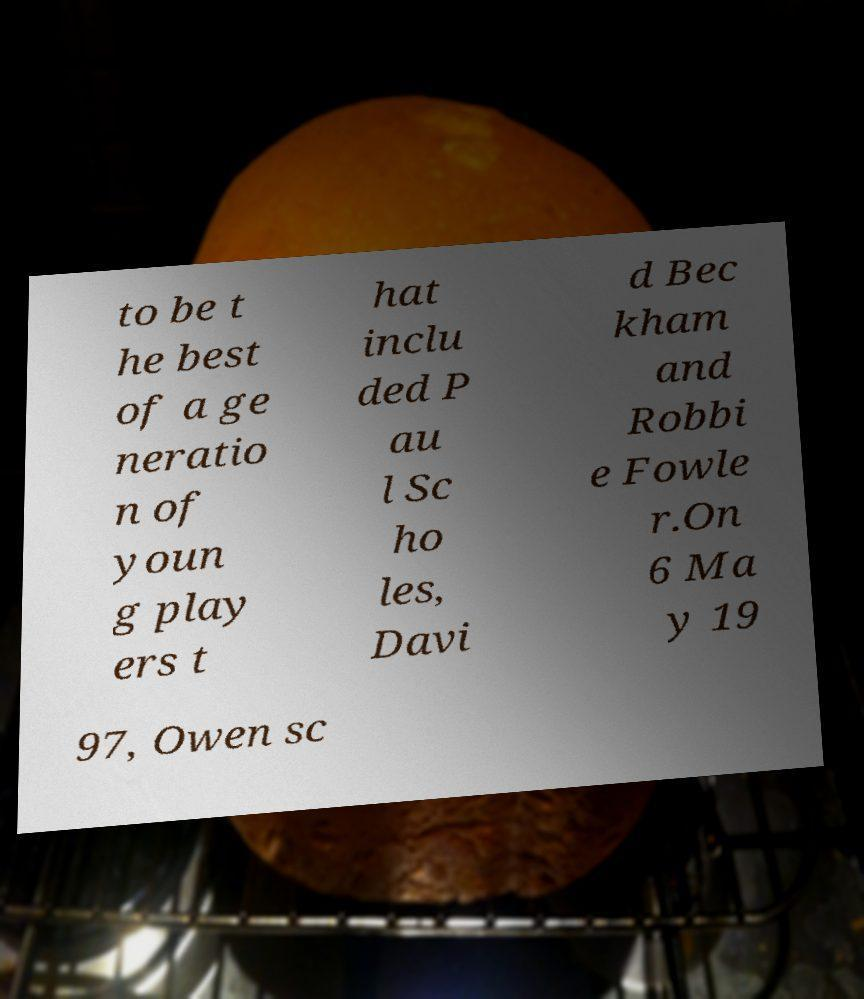Can you accurately transcribe the text from the provided image for me? to be t he best of a ge neratio n of youn g play ers t hat inclu ded P au l Sc ho les, Davi d Bec kham and Robbi e Fowle r.On 6 Ma y 19 97, Owen sc 